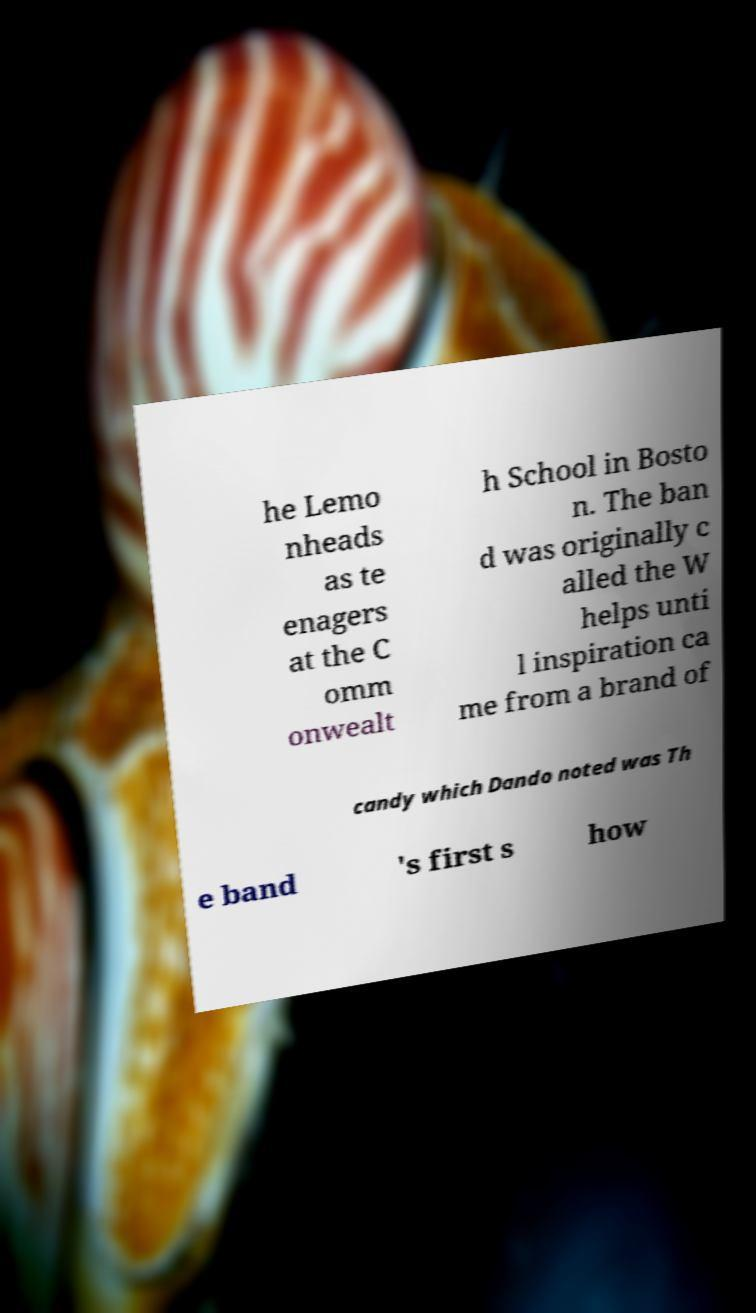For documentation purposes, I need the text within this image transcribed. Could you provide that? he Lemo nheads as te enagers at the C omm onwealt h School in Bosto n. The ban d was originally c alled the W helps unti l inspiration ca me from a brand of candy which Dando noted was Th e band 's first s how 